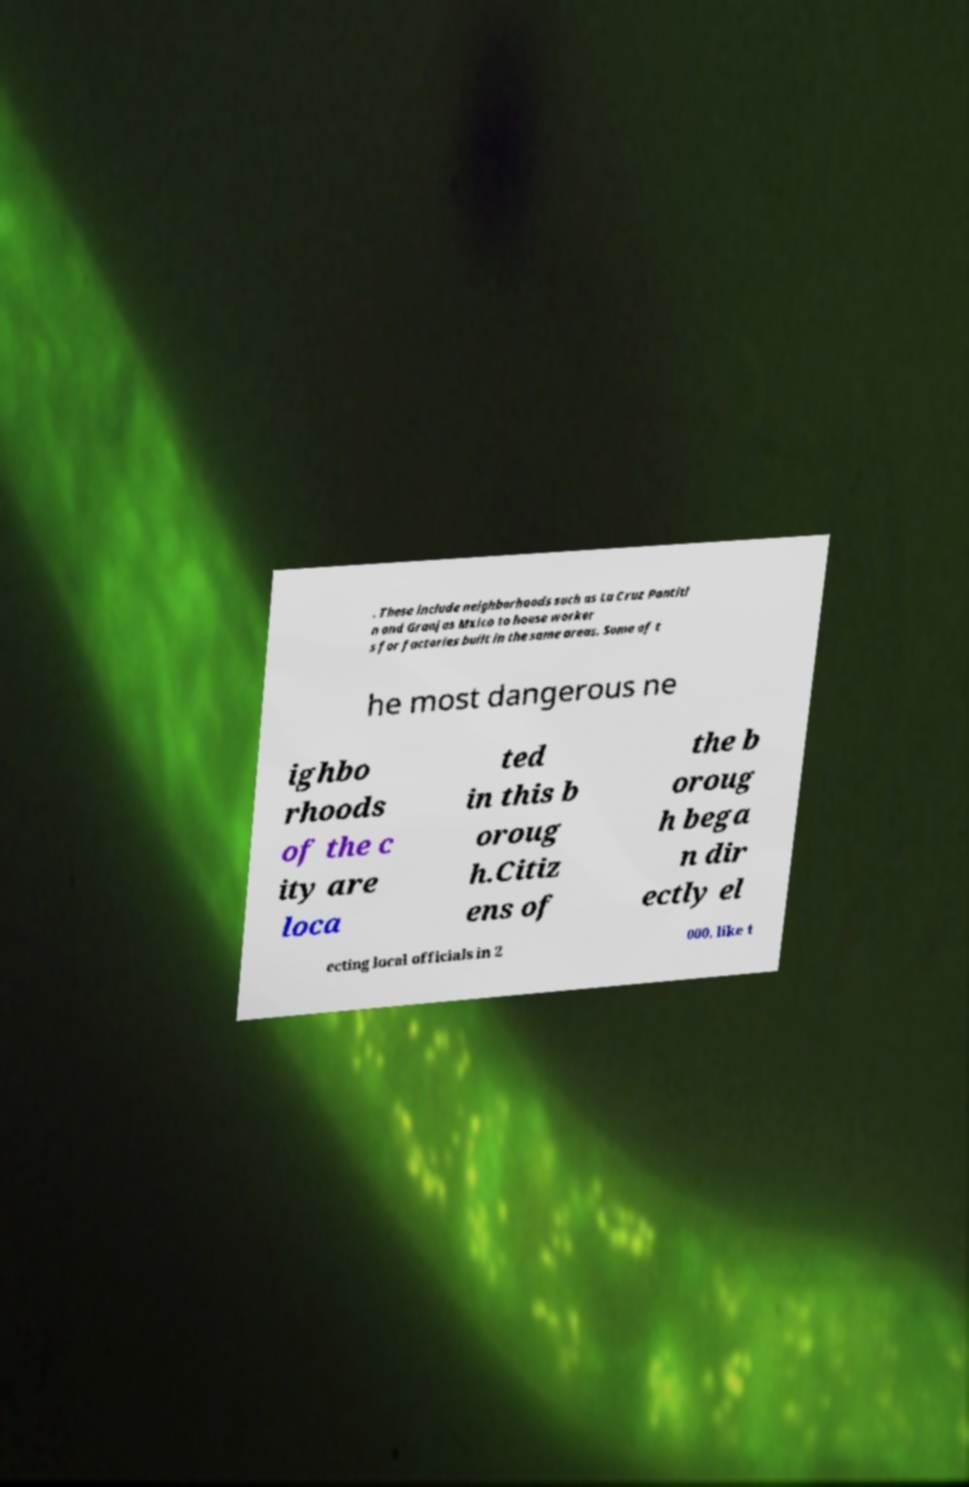For documentation purposes, I need the text within this image transcribed. Could you provide that? . These include neighborhoods such as La Cruz Pantitl n and Granjas Mxico to house worker s for factories built in the same areas. Some of t he most dangerous ne ighbo rhoods of the c ity are loca ted in this b oroug h.Citiz ens of the b oroug h bega n dir ectly el ecting local officials in 2 000, like t 